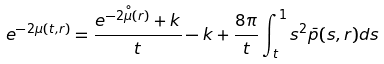Convert formula to latex. <formula><loc_0><loc_0><loc_500><loc_500>e ^ { - 2 \mu ( t , r ) } = \frac { e ^ { - 2 \overset { \circ } { \mu } ( r ) } + k } { t } - k + \frac { 8 \pi } { t } \int _ { t } ^ { 1 } s ^ { 2 } \bar { p } ( s , r ) d s</formula> 